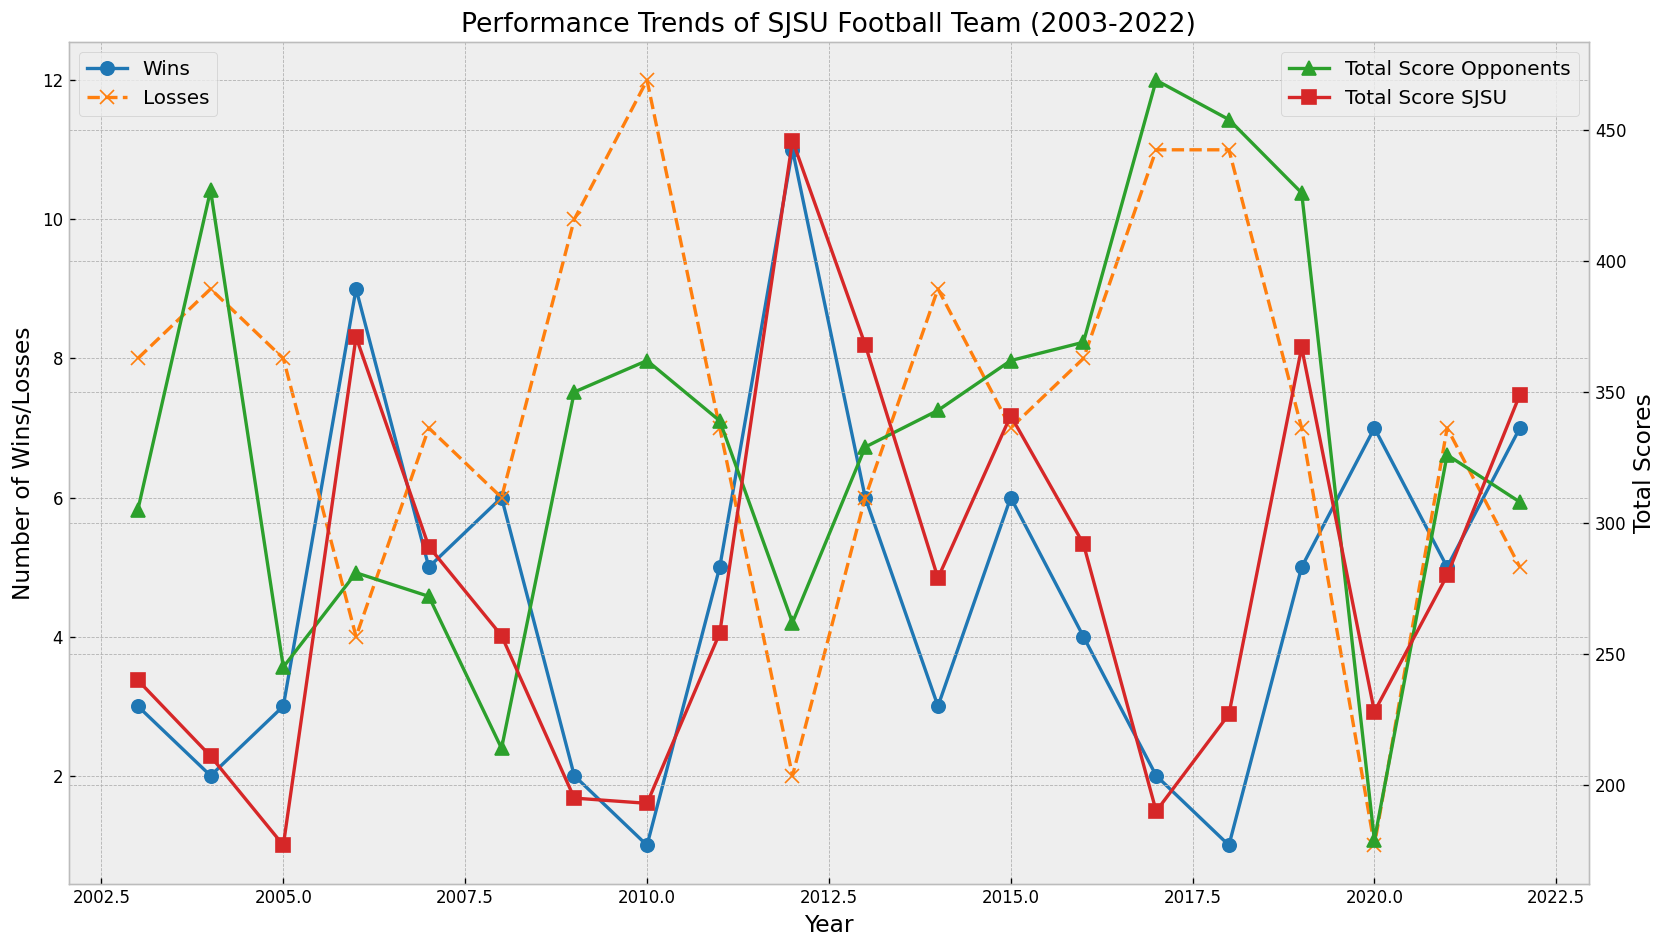what is the total number of wins in 2006 and 2012? In 2006, the wins are marked with a blue dot, and in 2012, the wins are likewise shown with a blue dot. Summing the wins of these two years (9 for 2006 and 11 for 2012) gives us 9 + 11 = 20.
Answer: 20 Which year had the highest number of losses? Each year is represented with an orange "x" marker for losses. The highest point for these markers corresponds to 2010 with 12 losses.
Answer: 2010 In which year did SJSU have a higher total score than their opponents, but fewer than 10 wins? Looking at the red square markers for SJSU's total scores and comparing them with the green triangle markers for opponents’ scores, 2006 and 2013 has SJSU scoring higher. In these years, SJSU had fewer than 10 wins.
Answer: 2006, 2013 Which year had the closest total scores between SJSU and their opponents? By visually inspecting the lines of red squares and green triangles where they are nearest, the closest proximity appears in 2015 where both scores are nearly equal.
Answer: 2015 In which years did SJSU have 7 wins? The blue dots indicate wins in each year, and visually counting for 7 wins, the years that match are 2020 and 2022.
Answer: 2020, 2022 How many more total points did SJSU score compared to their opponents in 2012? In 2012, the red square marker for SJSU is at 446, and the green triangle for opponents is at 262. Calculating the difference, 446 - 262 = 184.
Answer: 184 What is the average number of wins over the 20 years? To find the average, sum up all the wins across the years and then divide by the number of years: (3 + 2 + 3 + 9 + 5 + 6 + 2 + 1 + 5 + 11 + 6 + 3 + 6 + 4 + 2 + 1 + 5 + 7 + 5 + 7) / 20 = 4.65.
Answer: 4.65 In which year did SJSU have both the highest total scores and the highest number of wins? Observing the red squares for the highest score (which is 446) and blue dots for the highest number of wins (which is 11) leads to the year 2012.
Answer: 2012 